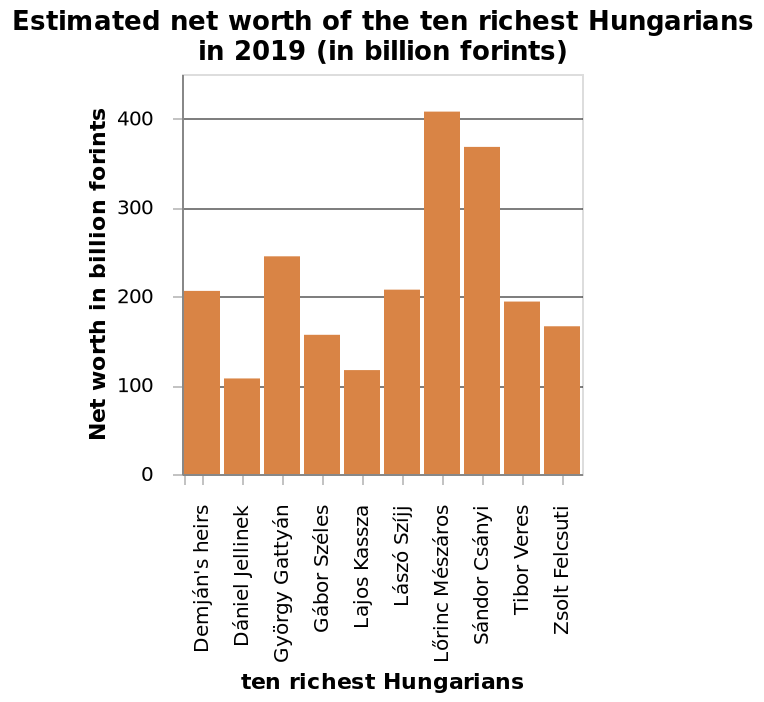<image>
What is the wealth of Lorinc Meszaros in 2019?  Lorinc Meszaros has a wealth of over 400 million forints in 2019. Offer a thorough analysis of the image. The graph shows Lorinc Meszaros to be the wealthiest Hungarian, with a wealth of over 400 million forints in 2019. In the top 10, Daniel Jellinek is the least wealthy of these having wealth of just over 100 million forints. Which year does the bar diagram represent the estimated net worth of the ten richest Hungarians? The bar diagram represents the estimated net worth of the ten richest Hungarians in 2019. 